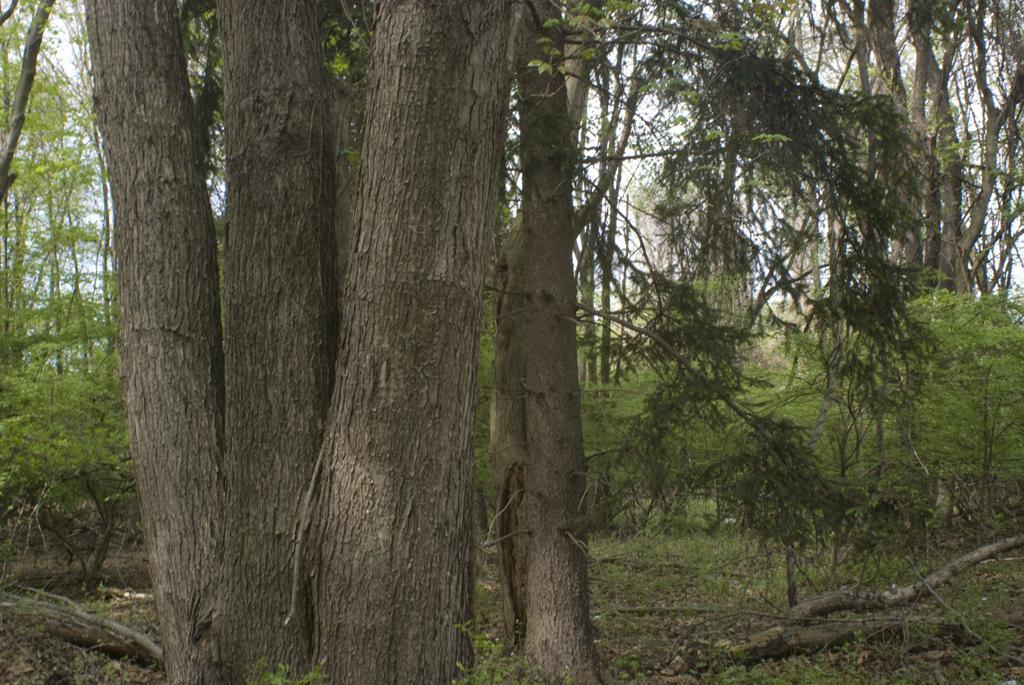In one or two sentences, can you explain what this image depicts? There is a tree trunk and behind the tree there are many tall trees and plants. 